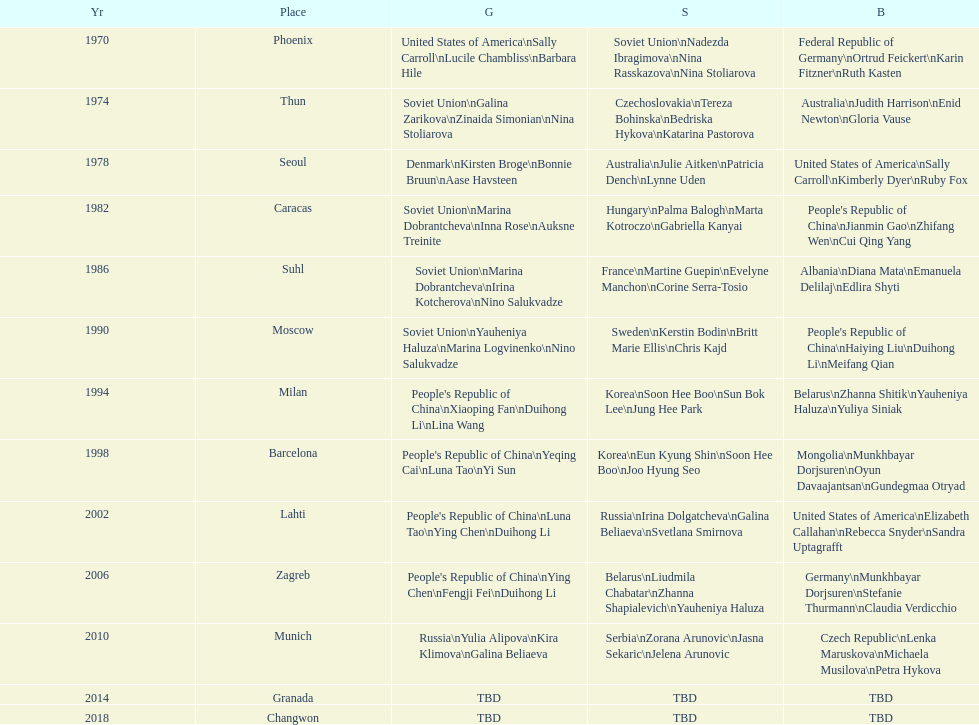What are the total number of times the soviet union is listed under the gold column? 4. 